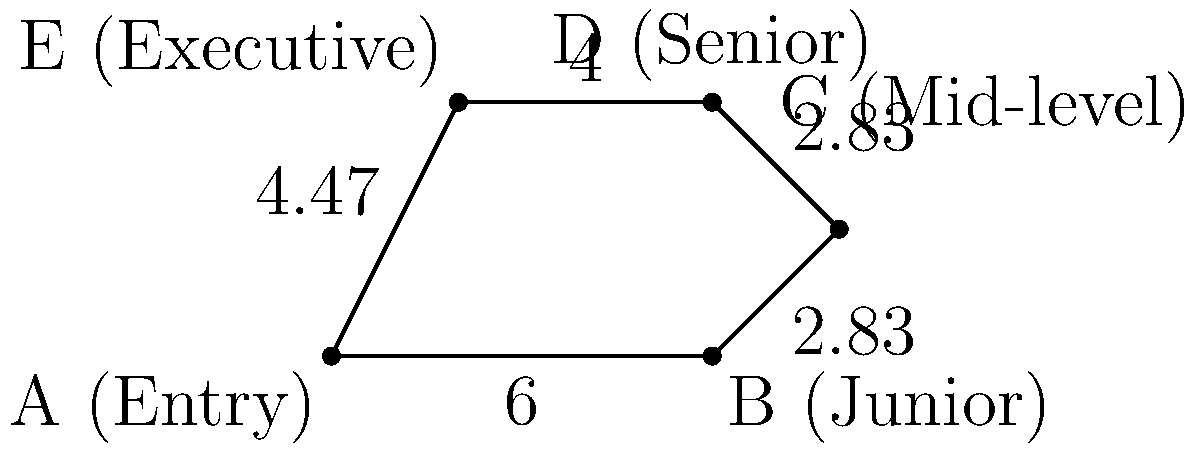The irregular polygon ABCDE represents different tiers of employee compensation in a company, from entry-level to executive. Given that the lengths of the sides are AB = 6 units, BC ≈ 2.83 units, CD ≈ 2.83 units, DE = 4 units, and EA ≈ 4.47 units, calculate the perimeter of the polygon. Round your answer to two decimal places. To calculate the perimeter of the irregular polygon, we need to sum up the lengths of all sides:

1. Side AB (Entry to Junior): 6 units
2. Side BC (Junior to Mid-level): 2.83 units
3. Side CD (Mid-level to Senior): 2.83 units
4. Side DE (Senior to Executive): 4 units
5. Side EA (Executive to Entry): 4.47 units

Perimeter = AB + BC + CD + DE + EA
          = 6 + 2.83 + 2.83 + 4 + 4.47
          = 20.13 units

Rounding to two decimal places: 20.13 units
Answer: 20.13 units 